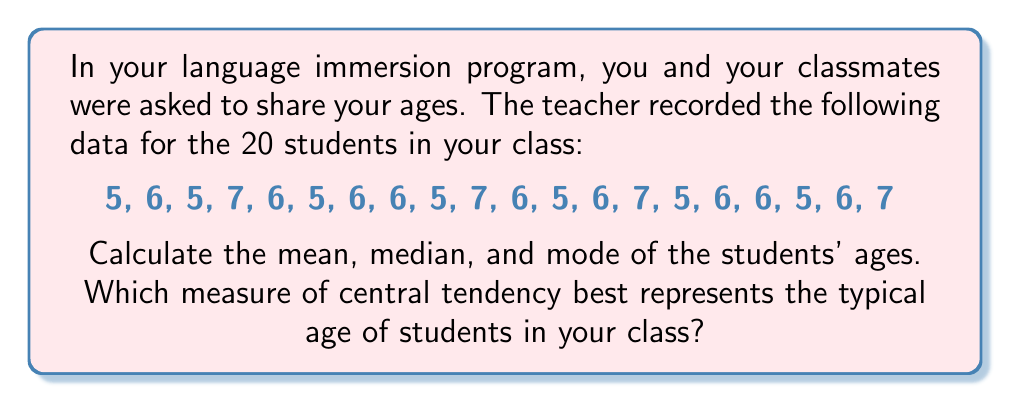Could you help me with this problem? Let's calculate each measure of central tendency:

1. Mean:
The mean is the average of all values.

$$ \text{Mean} = \frac{\text{Sum of all values}}{\text{Number of values}} $$

Sum of ages: $5 + 6 + 5 + 7 + 6 + 5 + 6 + 6 + 5 + 7 + 6 + 5 + 6 + 7 + 5 + 6 + 6 + 5 + 6 + 7 = 117$

$$ \text{Mean} = \frac{117}{20} = 5.85 \text{ years} $$

2. Median:
To find the median, we first need to arrange the data in ascending order:

5, 5, 5, 5, 5, 5, 6, 6, 6, 6, 6, 6, 6, 6, 6, 7, 7, 7, 7, 7

With 20 values, the median is the average of the 10th and 11th values.

$$ \text{Median} = \frac{6 + 6}{2} = 6 \text{ years} $$

3. Mode:
The mode is the value that appears most frequently.
5 appears 6 times
6 appears 9 times
7 appears 5 times

Therefore, the mode is 6 years.

To determine which measure best represents the typical age, we consider:
- The mean (5.85 years) is influenced by all values but isn't a whole number.
- The median (6 years) represents the middle value and is less affected by extreme values.
- The mode (6 years) represents the most common age.

In this case, both the median and mode are 6 years, which is also close to the mean. This suggests that 6 years is a good representation of the typical age in the class.
Answer: Mean: 5.85 years
Median: 6 years
Mode: 6 years

The median and mode (both 6 years) best represent the typical age of students in the class. 